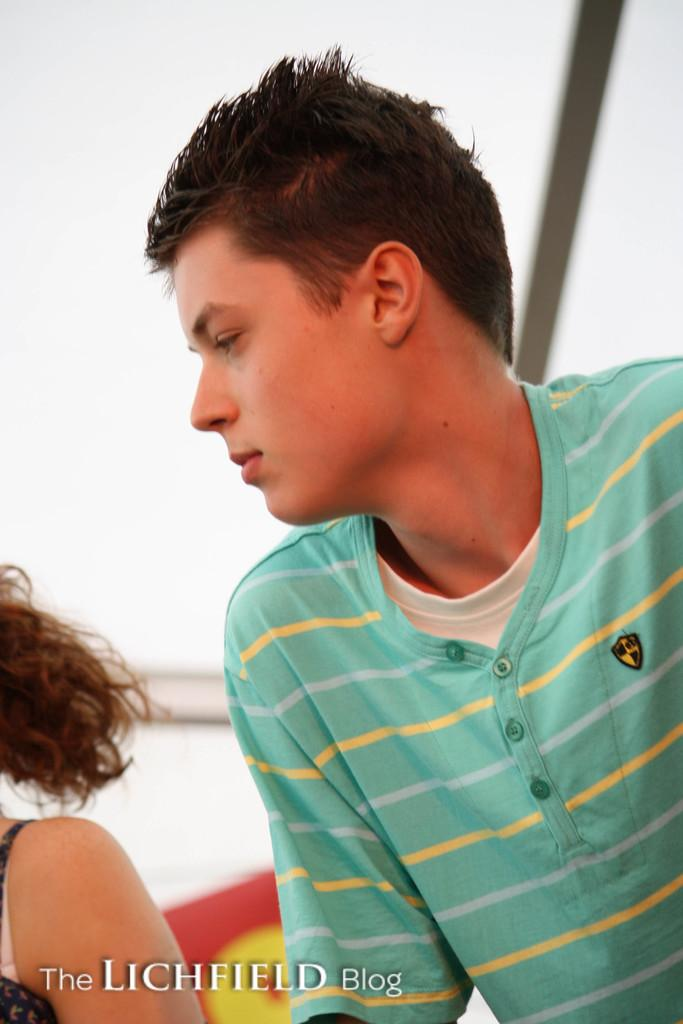What is the primary subject of the image? There is a person standing in the image. Can you describe the positioning of the second person in the image? There is another person behind the first person. Is there any text or marking visible in the image? Yes, there is a watermark at the bottom of the image. How many ants can be seen crawling on the person in the image? There are no ants visible in the image. What type of trains are passing by in the background of the image? There are no trains present in the image. 